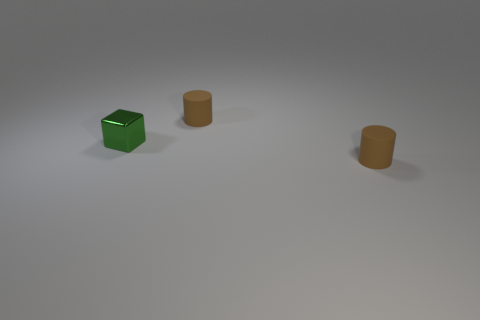There is a cylinder behind the tiny green block; does it have the same color as the cylinder in front of the tiny metallic block?
Your answer should be compact. Yes. What color is the block?
Your answer should be compact. Green. There is a matte object in front of the green metallic block to the left of the small brown cylinder behind the tiny green metal object; what is its size?
Your answer should be compact. Small. What number of other objects are the same shape as the small green thing?
Provide a short and direct response. 0. How many cubes are either small green metal objects or tiny things?
Offer a very short reply. 1. There is a shiny block that is to the left of the brown rubber thing that is left of the tiny cylinder that is in front of the tiny block; what is its color?
Offer a very short reply. Green. What number of green things are cylinders or tiny blocks?
Ensure brevity in your answer.  1. There is a metal cube; what number of tiny things are right of it?
Keep it short and to the point. 2. Are there more large gray things than small shiny cubes?
Offer a very short reply. No. What is the shape of the small brown rubber object that is on the left side of the small cylinder that is in front of the green object?
Provide a short and direct response. Cylinder. 